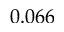<formula> <loc_0><loc_0><loc_500><loc_500>0 . 0 6 6</formula> 